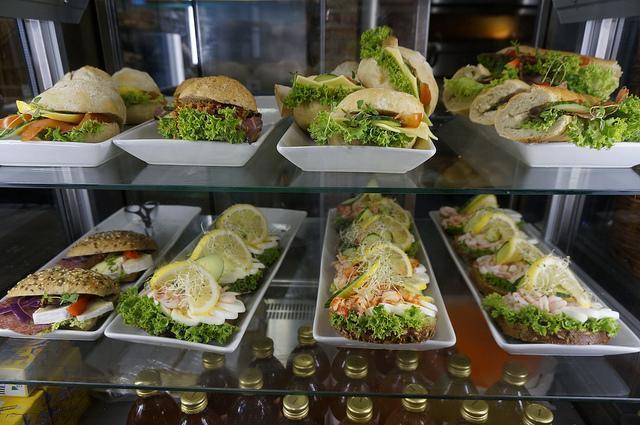How many sandwiches are there?
Give a very brief answer. 11. How many bottles are visible?
Give a very brief answer. 5. How many cows are there?
Give a very brief answer. 0. 